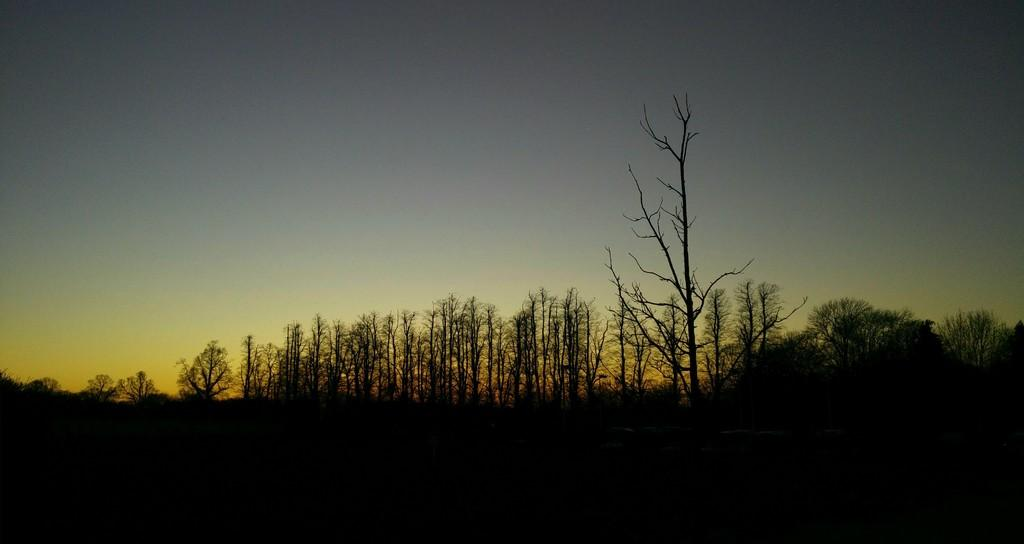What type of vegetation can be seen in the image? There are trees in the image. What part of the natural environment is visible in the image? The sky is visible in the image. What month is depicted in the image? The image does not depict a specific month; it only shows trees and the sky. Can you tell me how many ducks are swimming in the pond in the image? There is no pond or duck present in the image; it only features trees and the sky. 